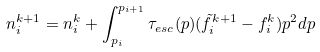Convert formula to latex. <formula><loc_0><loc_0><loc_500><loc_500>n _ { i } ^ { k + 1 } = n _ { i } ^ { k } + \int _ { p _ { i } } ^ { p _ { i + 1 } } \tau _ { e s c } ( p ) ( \tilde { f } _ { i } ^ { k + 1 } - f _ { i } ^ { k } ) p ^ { 2 } d p</formula> 